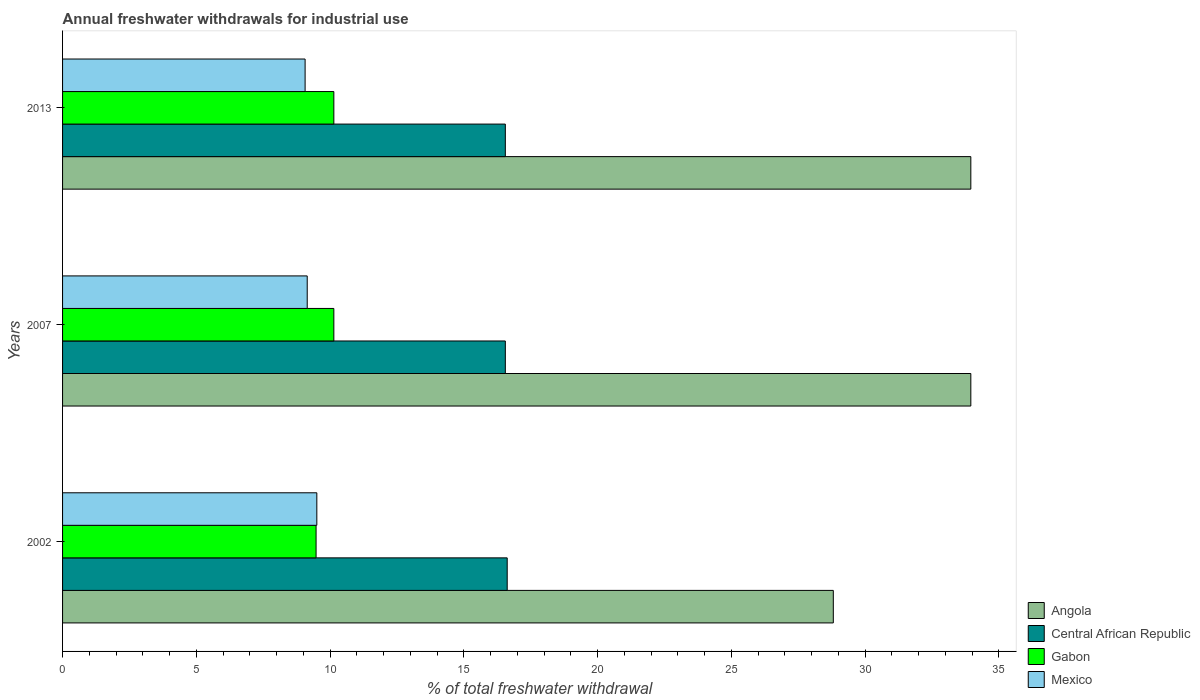How many groups of bars are there?
Your response must be concise. 3. Are the number of bars on each tick of the Y-axis equal?
Make the answer very short. Yes. What is the total annual withdrawals from freshwater in Central African Republic in 2007?
Give a very brief answer. 16.55. Across all years, what is the maximum total annual withdrawals from freshwater in Mexico?
Make the answer very short. 9.5. Across all years, what is the minimum total annual withdrawals from freshwater in Gabon?
Make the answer very short. 9.48. What is the total total annual withdrawals from freshwater in Mexico in the graph?
Make the answer very short. 27.72. What is the difference between the total annual withdrawals from freshwater in Mexico in 2002 and that in 2013?
Give a very brief answer. 0.44. What is the difference between the total annual withdrawals from freshwater in Mexico in 2007 and the total annual withdrawals from freshwater in Central African Republic in 2002?
Your answer should be compact. -7.48. What is the average total annual withdrawals from freshwater in Gabon per year?
Your answer should be compact. 9.92. In the year 2013, what is the difference between the total annual withdrawals from freshwater in Angola and total annual withdrawals from freshwater in Gabon?
Provide a short and direct response. 23.81. In how many years, is the total annual withdrawals from freshwater in Angola greater than 24 %?
Give a very brief answer. 3. What is the ratio of the total annual withdrawals from freshwater in Gabon in 2002 to that in 2013?
Give a very brief answer. 0.93. What is the difference between the highest and the second highest total annual withdrawals from freshwater in Angola?
Your answer should be compact. 0. What is the difference between the highest and the lowest total annual withdrawals from freshwater in Mexico?
Your response must be concise. 0.44. In how many years, is the total annual withdrawals from freshwater in Central African Republic greater than the average total annual withdrawals from freshwater in Central African Republic taken over all years?
Your answer should be very brief. 1. Is the sum of the total annual withdrawals from freshwater in Angola in 2002 and 2007 greater than the maximum total annual withdrawals from freshwater in Mexico across all years?
Ensure brevity in your answer.  Yes. What does the 2nd bar from the top in 2002 represents?
Provide a short and direct response. Gabon. What does the 1st bar from the bottom in 2007 represents?
Make the answer very short. Angola. Is it the case that in every year, the sum of the total annual withdrawals from freshwater in Mexico and total annual withdrawals from freshwater in Central African Republic is greater than the total annual withdrawals from freshwater in Angola?
Your answer should be compact. No. How many bars are there?
Offer a terse response. 12. Are all the bars in the graph horizontal?
Offer a terse response. Yes. How many years are there in the graph?
Your response must be concise. 3. Does the graph contain any zero values?
Make the answer very short. No. How many legend labels are there?
Offer a very short reply. 4. What is the title of the graph?
Give a very brief answer. Annual freshwater withdrawals for industrial use. Does "Bahrain" appear as one of the legend labels in the graph?
Provide a short and direct response. No. What is the label or title of the X-axis?
Provide a succinct answer. % of total freshwater withdrawal. What is the label or title of the Y-axis?
Make the answer very short. Years. What is the % of total freshwater withdrawal of Angola in 2002?
Make the answer very short. 28.81. What is the % of total freshwater withdrawal in Central African Republic in 2002?
Provide a succinct answer. 16.62. What is the % of total freshwater withdrawal of Gabon in 2002?
Keep it short and to the point. 9.48. What is the % of total freshwater withdrawal of Mexico in 2002?
Keep it short and to the point. 9.5. What is the % of total freshwater withdrawal of Angola in 2007?
Offer a terse response. 33.95. What is the % of total freshwater withdrawal in Central African Republic in 2007?
Keep it short and to the point. 16.55. What is the % of total freshwater withdrawal in Gabon in 2007?
Ensure brevity in your answer.  10.14. What is the % of total freshwater withdrawal of Mexico in 2007?
Provide a succinct answer. 9.14. What is the % of total freshwater withdrawal of Angola in 2013?
Offer a terse response. 33.95. What is the % of total freshwater withdrawal in Central African Republic in 2013?
Offer a very short reply. 16.55. What is the % of total freshwater withdrawal in Gabon in 2013?
Your answer should be compact. 10.14. What is the % of total freshwater withdrawal in Mexico in 2013?
Offer a very short reply. 9.07. Across all years, what is the maximum % of total freshwater withdrawal in Angola?
Give a very brief answer. 33.95. Across all years, what is the maximum % of total freshwater withdrawal of Central African Republic?
Provide a succinct answer. 16.62. Across all years, what is the maximum % of total freshwater withdrawal in Gabon?
Give a very brief answer. 10.14. Across all years, what is the maximum % of total freshwater withdrawal in Mexico?
Offer a very short reply. 9.5. Across all years, what is the minimum % of total freshwater withdrawal of Angola?
Your response must be concise. 28.81. Across all years, what is the minimum % of total freshwater withdrawal of Central African Republic?
Your response must be concise. 16.55. Across all years, what is the minimum % of total freshwater withdrawal in Gabon?
Your answer should be very brief. 9.48. Across all years, what is the minimum % of total freshwater withdrawal of Mexico?
Provide a succinct answer. 9.07. What is the total % of total freshwater withdrawal of Angola in the graph?
Keep it short and to the point. 96.71. What is the total % of total freshwater withdrawal of Central African Republic in the graph?
Provide a succinct answer. 49.72. What is the total % of total freshwater withdrawal in Gabon in the graph?
Make the answer very short. 29.76. What is the total % of total freshwater withdrawal of Mexico in the graph?
Ensure brevity in your answer.  27.71. What is the difference between the % of total freshwater withdrawal in Angola in 2002 and that in 2007?
Offer a very short reply. -5.14. What is the difference between the % of total freshwater withdrawal in Central African Republic in 2002 and that in 2007?
Your answer should be compact. 0.07. What is the difference between the % of total freshwater withdrawal in Gabon in 2002 and that in 2007?
Ensure brevity in your answer.  -0.66. What is the difference between the % of total freshwater withdrawal in Mexico in 2002 and that in 2007?
Your answer should be compact. 0.36. What is the difference between the % of total freshwater withdrawal in Angola in 2002 and that in 2013?
Your response must be concise. -5.14. What is the difference between the % of total freshwater withdrawal in Central African Republic in 2002 and that in 2013?
Your answer should be very brief. 0.07. What is the difference between the % of total freshwater withdrawal of Gabon in 2002 and that in 2013?
Give a very brief answer. -0.66. What is the difference between the % of total freshwater withdrawal in Mexico in 2002 and that in 2013?
Keep it short and to the point. 0.44. What is the difference between the % of total freshwater withdrawal of Angola in 2007 and that in 2013?
Provide a succinct answer. 0. What is the difference between the % of total freshwater withdrawal in Central African Republic in 2007 and that in 2013?
Give a very brief answer. 0. What is the difference between the % of total freshwater withdrawal in Gabon in 2007 and that in 2013?
Make the answer very short. 0. What is the difference between the % of total freshwater withdrawal of Mexico in 2007 and that in 2013?
Offer a very short reply. 0.08. What is the difference between the % of total freshwater withdrawal of Angola in 2002 and the % of total freshwater withdrawal of Central African Republic in 2007?
Your answer should be very brief. 12.26. What is the difference between the % of total freshwater withdrawal of Angola in 2002 and the % of total freshwater withdrawal of Gabon in 2007?
Your response must be concise. 18.67. What is the difference between the % of total freshwater withdrawal in Angola in 2002 and the % of total freshwater withdrawal in Mexico in 2007?
Make the answer very short. 19.66. What is the difference between the % of total freshwater withdrawal of Central African Republic in 2002 and the % of total freshwater withdrawal of Gabon in 2007?
Ensure brevity in your answer.  6.48. What is the difference between the % of total freshwater withdrawal of Central African Republic in 2002 and the % of total freshwater withdrawal of Mexico in 2007?
Give a very brief answer. 7.47. What is the difference between the % of total freshwater withdrawal of Gabon in 2002 and the % of total freshwater withdrawal of Mexico in 2007?
Give a very brief answer. 0.33. What is the difference between the % of total freshwater withdrawal of Angola in 2002 and the % of total freshwater withdrawal of Central African Republic in 2013?
Give a very brief answer. 12.26. What is the difference between the % of total freshwater withdrawal in Angola in 2002 and the % of total freshwater withdrawal in Gabon in 2013?
Keep it short and to the point. 18.67. What is the difference between the % of total freshwater withdrawal of Angola in 2002 and the % of total freshwater withdrawal of Mexico in 2013?
Offer a terse response. 19.74. What is the difference between the % of total freshwater withdrawal in Central African Republic in 2002 and the % of total freshwater withdrawal in Gabon in 2013?
Keep it short and to the point. 6.48. What is the difference between the % of total freshwater withdrawal in Central African Republic in 2002 and the % of total freshwater withdrawal in Mexico in 2013?
Your answer should be very brief. 7.55. What is the difference between the % of total freshwater withdrawal in Gabon in 2002 and the % of total freshwater withdrawal in Mexico in 2013?
Offer a very short reply. 0.41. What is the difference between the % of total freshwater withdrawal of Angola in 2007 and the % of total freshwater withdrawal of Gabon in 2013?
Give a very brief answer. 23.81. What is the difference between the % of total freshwater withdrawal of Angola in 2007 and the % of total freshwater withdrawal of Mexico in 2013?
Make the answer very short. 24.88. What is the difference between the % of total freshwater withdrawal in Central African Republic in 2007 and the % of total freshwater withdrawal in Gabon in 2013?
Provide a succinct answer. 6.41. What is the difference between the % of total freshwater withdrawal of Central African Republic in 2007 and the % of total freshwater withdrawal of Mexico in 2013?
Your answer should be compact. 7.48. What is the difference between the % of total freshwater withdrawal in Gabon in 2007 and the % of total freshwater withdrawal in Mexico in 2013?
Provide a short and direct response. 1.07. What is the average % of total freshwater withdrawal in Angola per year?
Give a very brief answer. 32.24. What is the average % of total freshwater withdrawal of Central African Republic per year?
Ensure brevity in your answer.  16.57. What is the average % of total freshwater withdrawal of Gabon per year?
Your response must be concise. 9.92. What is the average % of total freshwater withdrawal in Mexico per year?
Offer a terse response. 9.24. In the year 2002, what is the difference between the % of total freshwater withdrawal in Angola and % of total freshwater withdrawal in Central African Republic?
Provide a short and direct response. 12.19. In the year 2002, what is the difference between the % of total freshwater withdrawal in Angola and % of total freshwater withdrawal in Gabon?
Provide a short and direct response. 19.33. In the year 2002, what is the difference between the % of total freshwater withdrawal in Angola and % of total freshwater withdrawal in Mexico?
Your answer should be compact. 19.31. In the year 2002, what is the difference between the % of total freshwater withdrawal of Central African Republic and % of total freshwater withdrawal of Gabon?
Offer a very short reply. 7.14. In the year 2002, what is the difference between the % of total freshwater withdrawal in Central African Republic and % of total freshwater withdrawal in Mexico?
Offer a terse response. 7.12. In the year 2002, what is the difference between the % of total freshwater withdrawal of Gabon and % of total freshwater withdrawal of Mexico?
Offer a very short reply. -0.03. In the year 2007, what is the difference between the % of total freshwater withdrawal in Angola and % of total freshwater withdrawal in Central African Republic?
Your answer should be compact. 17.4. In the year 2007, what is the difference between the % of total freshwater withdrawal in Angola and % of total freshwater withdrawal in Gabon?
Make the answer very short. 23.81. In the year 2007, what is the difference between the % of total freshwater withdrawal of Angola and % of total freshwater withdrawal of Mexico?
Offer a very short reply. 24.8. In the year 2007, what is the difference between the % of total freshwater withdrawal of Central African Republic and % of total freshwater withdrawal of Gabon?
Provide a short and direct response. 6.41. In the year 2007, what is the difference between the % of total freshwater withdrawal in Central African Republic and % of total freshwater withdrawal in Mexico?
Provide a short and direct response. 7.41. In the year 2013, what is the difference between the % of total freshwater withdrawal of Angola and % of total freshwater withdrawal of Central African Republic?
Your response must be concise. 17.4. In the year 2013, what is the difference between the % of total freshwater withdrawal of Angola and % of total freshwater withdrawal of Gabon?
Provide a short and direct response. 23.81. In the year 2013, what is the difference between the % of total freshwater withdrawal of Angola and % of total freshwater withdrawal of Mexico?
Ensure brevity in your answer.  24.88. In the year 2013, what is the difference between the % of total freshwater withdrawal in Central African Republic and % of total freshwater withdrawal in Gabon?
Ensure brevity in your answer.  6.41. In the year 2013, what is the difference between the % of total freshwater withdrawal of Central African Republic and % of total freshwater withdrawal of Mexico?
Provide a short and direct response. 7.48. In the year 2013, what is the difference between the % of total freshwater withdrawal of Gabon and % of total freshwater withdrawal of Mexico?
Make the answer very short. 1.07. What is the ratio of the % of total freshwater withdrawal of Angola in 2002 to that in 2007?
Provide a short and direct response. 0.85. What is the ratio of the % of total freshwater withdrawal in Central African Republic in 2002 to that in 2007?
Your answer should be very brief. 1. What is the ratio of the % of total freshwater withdrawal of Gabon in 2002 to that in 2007?
Offer a terse response. 0.93. What is the ratio of the % of total freshwater withdrawal in Mexico in 2002 to that in 2007?
Offer a very short reply. 1.04. What is the ratio of the % of total freshwater withdrawal of Angola in 2002 to that in 2013?
Your answer should be very brief. 0.85. What is the ratio of the % of total freshwater withdrawal in Central African Republic in 2002 to that in 2013?
Give a very brief answer. 1. What is the ratio of the % of total freshwater withdrawal in Gabon in 2002 to that in 2013?
Offer a very short reply. 0.93. What is the ratio of the % of total freshwater withdrawal of Mexico in 2002 to that in 2013?
Offer a terse response. 1.05. What is the ratio of the % of total freshwater withdrawal of Angola in 2007 to that in 2013?
Provide a short and direct response. 1. What is the ratio of the % of total freshwater withdrawal in Gabon in 2007 to that in 2013?
Your response must be concise. 1. What is the ratio of the % of total freshwater withdrawal in Mexico in 2007 to that in 2013?
Your answer should be very brief. 1.01. What is the difference between the highest and the second highest % of total freshwater withdrawal in Angola?
Give a very brief answer. 0. What is the difference between the highest and the second highest % of total freshwater withdrawal in Central African Republic?
Keep it short and to the point. 0.07. What is the difference between the highest and the second highest % of total freshwater withdrawal in Gabon?
Provide a short and direct response. 0. What is the difference between the highest and the second highest % of total freshwater withdrawal in Mexico?
Ensure brevity in your answer.  0.36. What is the difference between the highest and the lowest % of total freshwater withdrawal of Angola?
Make the answer very short. 5.14. What is the difference between the highest and the lowest % of total freshwater withdrawal in Central African Republic?
Your response must be concise. 0.07. What is the difference between the highest and the lowest % of total freshwater withdrawal of Gabon?
Your response must be concise. 0.66. What is the difference between the highest and the lowest % of total freshwater withdrawal of Mexico?
Ensure brevity in your answer.  0.44. 